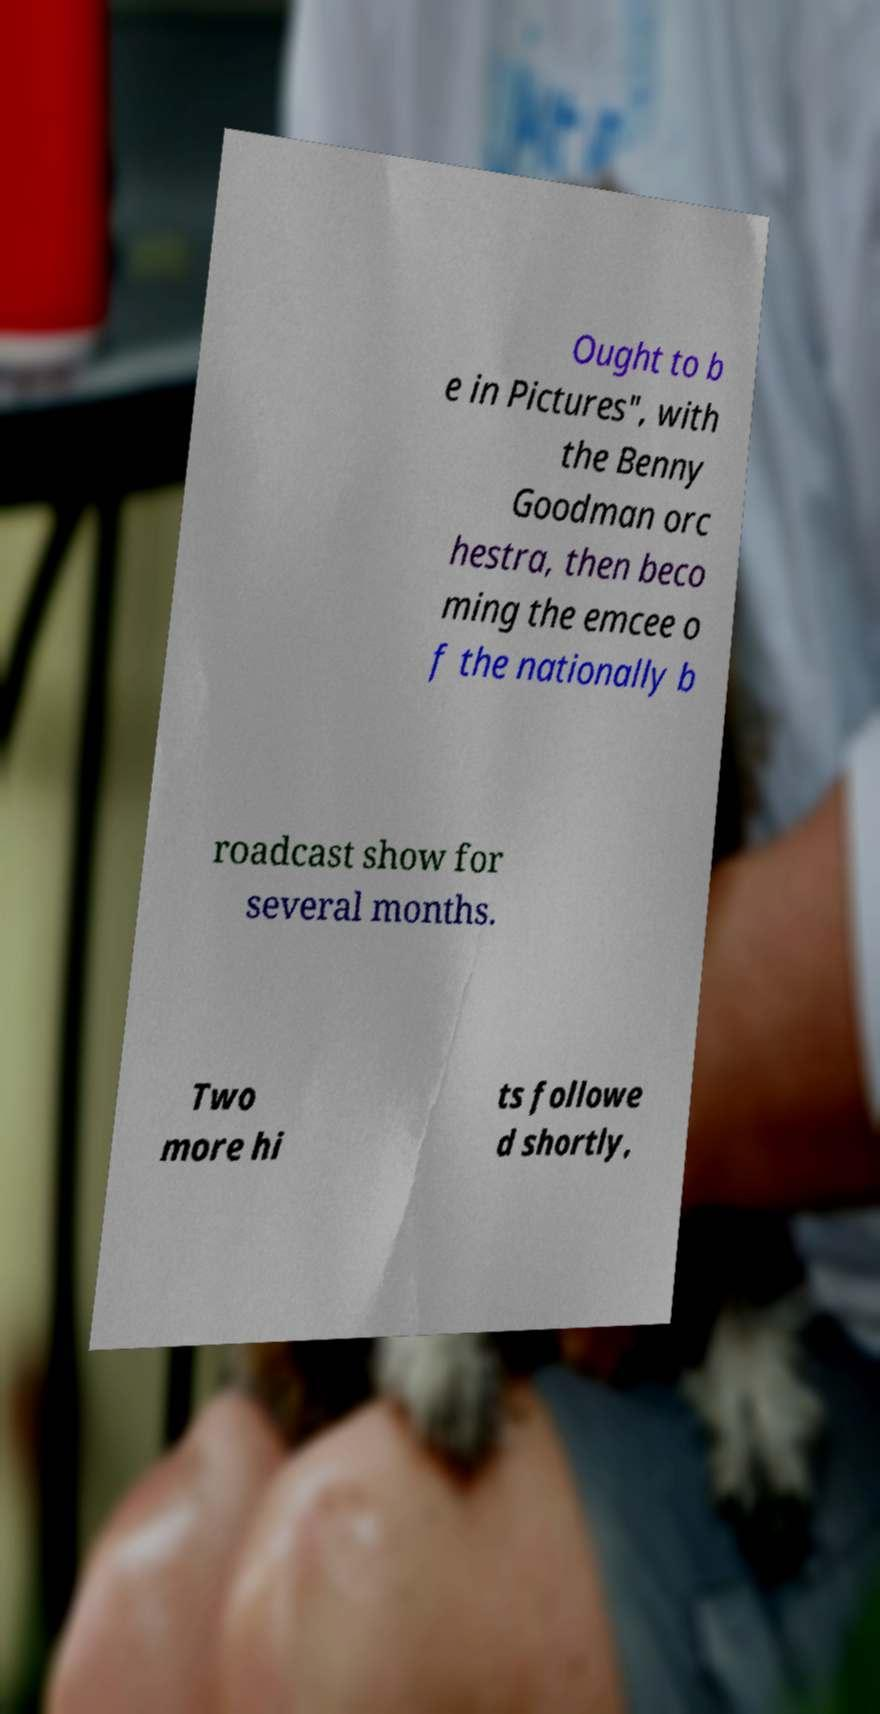Could you extract and type out the text from this image? Ought to b e in Pictures", with the Benny Goodman orc hestra, then beco ming the emcee o f the nationally b roadcast show for several months. Two more hi ts followe d shortly, 